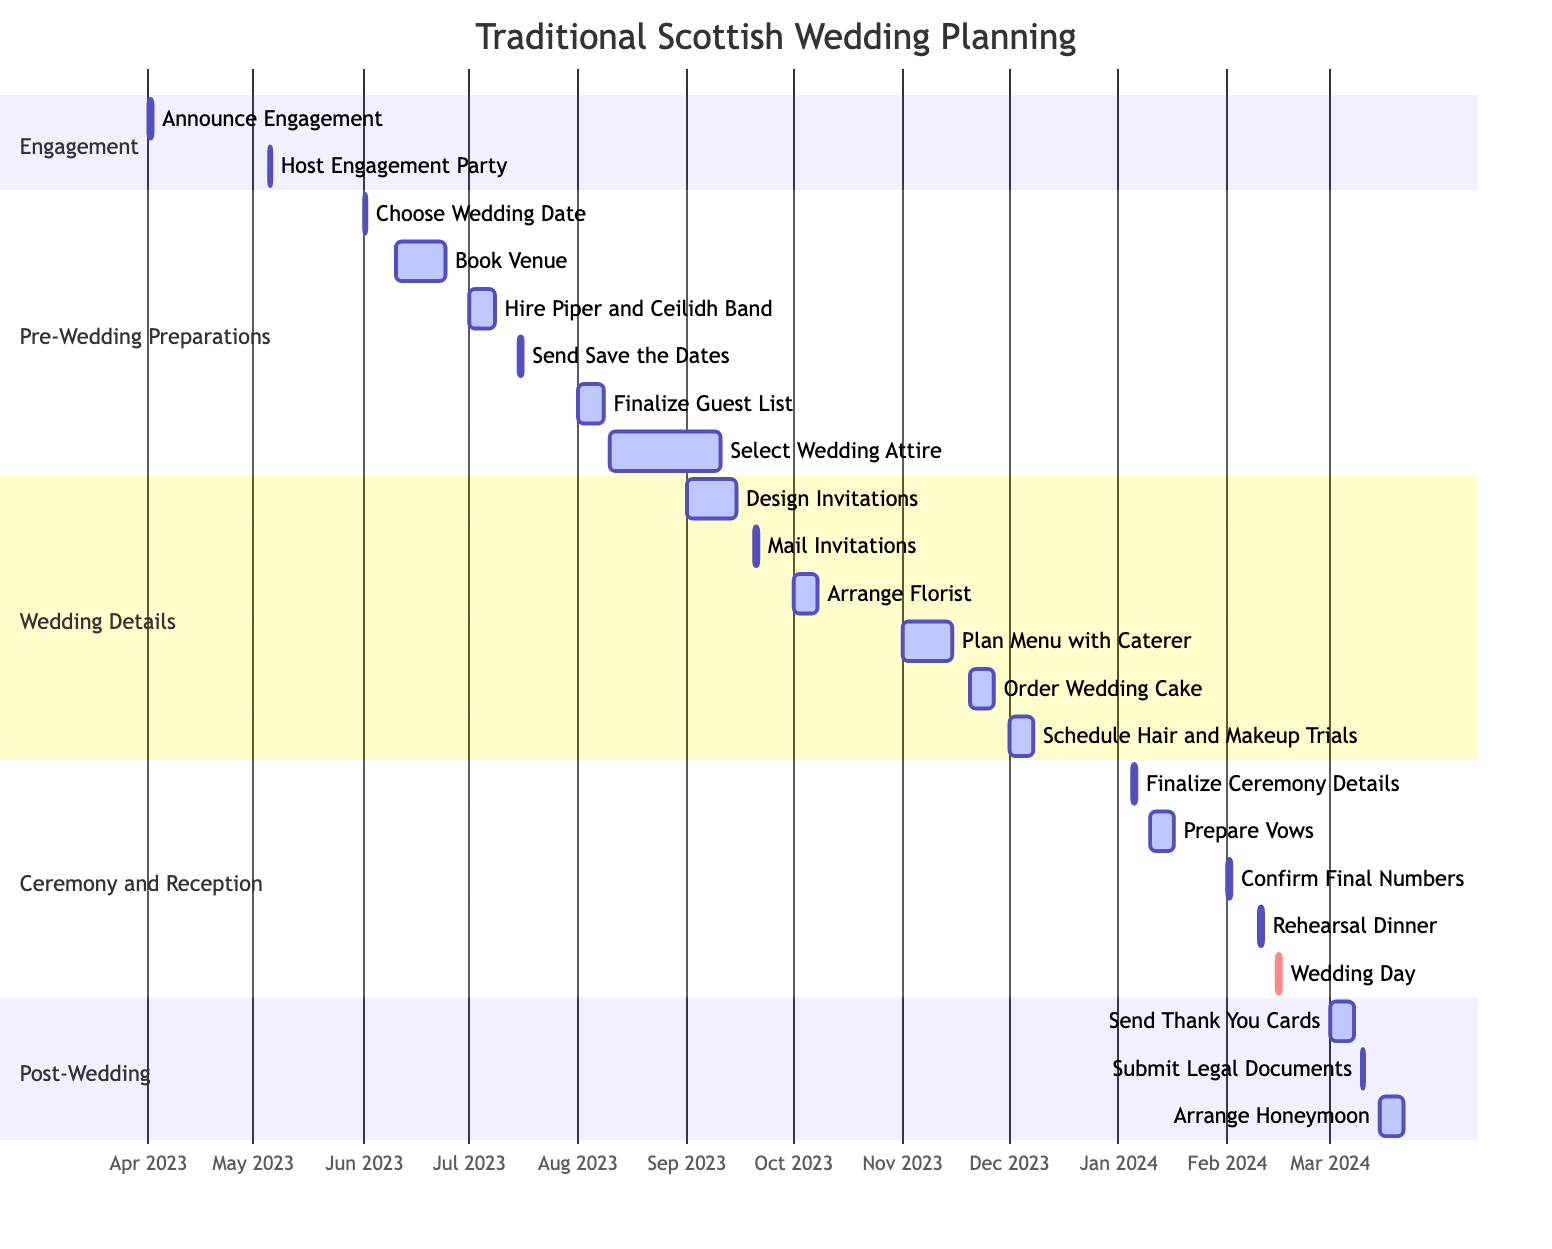What is the first milestone in the wedding planning process? The diagram clearly shows that "Engagement" is the first milestone listed. It is the first section before any other milestones in the Gantt chart.
Answer: Engagement How many weeks is the duration for booking the venue? Looking at the "Book Venue" task under the "Pre-Wedding Preparations" section, it shows a duration of "2 weeks."
Answer: 2 weeks What task occurs immediately after hosting the engagement party? The diagram indicates that the "Choose Wedding Date" task follows the "Host Engagement Party," which is the next task in the timeline after May 5th.
Answer: Choose Wedding Date Which task has the latest start date in the Post-Wedding Responsibilities? Referring to the "Post-Wedding Responsibilities" section, the task "Arrange Honeymoon" starts on March 15, 2024, which is the last date in that section.
Answer: Arrange Honeymoon What is the duration for the preparation of vows? Under the "Ceremony and Reception" section, the "Prepare Vows" task is shown with a duration of "1 week," indicating how long it will take.
Answer: 1 week What task is scheduled to happen on January 5, 2024? By reviewing the "Ceremony and Reception" section, one can see that "Finalize Ceremony Details with Officiant" is assigned to this exact date.
Answer: Finalize Ceremony Details with Officiant What is the total duration of tasks listed under the Wedding Details milestone? The tasks in the "Wedding Details" section collectively span from September 1, 2023, to December 8, 2023, adding up to a duration of about 14 weeks in total when counting all specified weeks and days.
Answer: 14 weeks What responsibility occurs directly before the wedding day? The "Rehearsal Dinner" task is listed immediately before the "Wedding Day" task in the timeline, indicating its sequence.
Answer: Rehearsal Dinner How long before the wedding day is the finalization of ceremony details scheduled? The "Finalize Ceremony Details with Officiant" task is set for January 5, 2024, while the "Wedding Day" is on February 15, indicating this task occurs 40 days prior to that date.
Answer: 40 days 